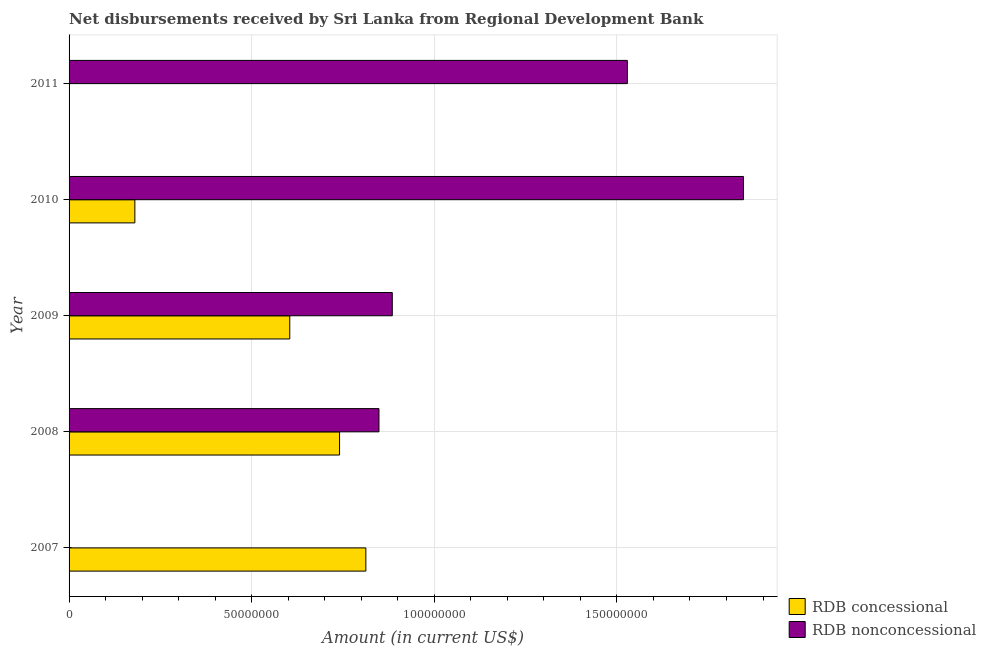How many bars are there on the 3rd tick from the top?
Your response must be concise. 2. What is the label of the 5th group of bars from the top?
Your answer should be compact. 2007. In how many cases, is the number of bars for a given year not equal to the number of legend labels?
Keep it short and to the point. 2. What is the net concessional disbursements from rdb in 2010?
Give a very brief answer. 1.80e+07. Across all years, what is the maximum net non concessional disbursements from rdb?
Your response must be concise. 1.85e+08. Across all years, what is the minimum net concessional disbursements from rdb?
Your response must be concise. 0. What is the total net non concessional disbursements from rdb in the graph?
Give a very brief answer. 5.11e+08. What is the difference between the net concessional disbursements from rdb in 2009 and that in 2010?
Offer a very short reply. 4.24e+07. What is the difference between the net concessional disbursements from rdb in 2007 and the net non concessional disbursements from rdb in 2010?
Your response must be concise. -1.03e+08. What is the average net concessional disbursements from rdb per year?
Give a very brief answer. 4.67e+07. In the year 2010, what is the difference between the net non concessional disbursements from rdb and net concessional disbursements from rdb?
Provide a short and direct response. 1.67e+08. What is the ratio of the net non concessional disbursements from rdb in 2009 to that in 2011?
Keep it short and to the point. 0.58. Is the net concessional disbursements from rdb in 2008 less than that in 2010?
Make the answer very short. No. What is the difference between the highest and the second highest net non concessional disbursements from rdb?
Offer a terse response. 3.18e+07. What is the difference between the highest and the lowest net concessional disbursements from rdb?
Make the answer very short. 8.13e+07. Are all the bars in the graph horizontal?
Provide a short and direct response. Yes. What is the difference between two consecutive major ticks on the X-axis?
Make the answer very short. 5.00e+07. Are the values on the major ticks of X-axis written in scientific E-notation?
Your answer should be very brief. No. Does the graph contain grids?
Make the answer very short. Yes. Where does the legend appear in the graph?
Offer a very short reply. Bottom right. What is the title of the graph?
Give a very brief answer. Net disbursements received by Sri Lanka from Regional Development Bank. Does "Non-pregnant women" appear as one of the legend labels in the graph?
Your answer should be compact. No. What is the label or title of the X-axis?
Give a very brief answer. Amount (in current US$). What is the label or title of the Y-axis?
Your answer should be very brief. Year. What is the Amount (in current US$) in RDB concessional in 2007?
Make the answer very short. 8.13e+07. What is the Amount (in current US$) of RDB nonconcessional in 2007?
Ensure brevity in your answer.  0. What is the Amount (in current US$) of RDB concessional in 2008?
Provide a succinct answer. 7.41e+07. What is the Amount (in current US$) of RDB nonconcessional in 2008?
Offer a terse response. 8.48e+07. What is the Amount (in current US$) of RDB concessional in 2009?
Give a very brief answer. 6.04e+07. What is the Amount (in current US$) of RDB nonconcessional in 2009?
Give a very brief answer. 8.85e+07. What is the Amount (in current US$) of RDB concessional in 2010?
Your answer should be very brief. 1.80e+07. What is the Amount (in current US$) of RDB nonconcessional in 2010?
Make the answer very short. 1.85e+08. What is the Amount (in current US$) of RDB nonconcessional in 2011?
Ensure brevity in your answer.  1.53e+08. Across all years, what is the maximum Amount (in current US$) in RDB concessional?
Offer a very short reply. 8.13e+07. Across all years, what is the maximum Amount (in current US$) of RDB nonconcessional?
Provide a succinct answer. 1.85e+08. Across all years, what is the minimum Amount (in current US$) in RDB nonconcessional?
Offer a terse response. 0. What is the total Amount (in current US$) of RDB concessional in the graph?
Provide a succinct answer. 2.34e+08. What is the total Amount (in current US$) of RDB nonconcessional in the graph?
Keep it short and to the point. 5.11e+08. What is the difference between the Amount (in current US$) of RDB concessional in 2007 and that in 2008?
Keep it short and to the point. 7.20e+06. What is the difference between the Amount (in current US$) of RDB concessional in 2007 and that in 2009?
Provide a short and direct response. 2.08e+07. What is the difference between the Amount (in current US$) in RDB concessional in 2007 and that in 2010?
Your answer should be very brief. 6.32e+07. What is the difference between the Amount (in current US$) of RDB concessional in 2008 and that in 2009?
Keep it short and to the point. 1.36e+07. What is the difference between the Amount (in current US$) of RDB nonconcessional in 2008 and that in 2009?
Provide a short and direct response. -3.64e+06. What is the difference between the Amount (in current US$) in RDB concessional in 2008 and that in 2010?
Your answer should be very brief. 5.60e+07. What is the difference between the Amount (in current US$) of RDB nonconcessional in 2008 and that in 2010?
Offer a very short reply. -9.98e+07. What is the difference between the Amount (in current US$) in RDB nonconcessional in 2008 and that in 2011?
Your response must be concise. -6.80e+07. What is the difference between the Amount (in current US$) of RDB concessional in 2009 and that in 2010?
Offer a terse response. 4.24e+07. What is the difference between the Amount (in current US$) of RDB nonconcessional in 2009 and that in 2010?
Give a very brief answer. -9.62e+07. What is the difference between the Amount (in current US$) of RDB nonconcessional in 2009 and that in 2011?
Provide a succinct answer. -6.44e+07. What is the difference between the Amount (in current US$) of RDB nonconcessional in 2010 and that in 2011?
Keep it short and to the point. 3.18e+07. What is the difference between the Amount (in current US$) of RDB concessional in 2007 and the Amount (in current US$) of RDB nonconcessional in 2008?
Keep it short and to the point. -3.59e+06. What is the difference between the Amount (in current US$) of RDB concessional in 2007 and the Amount (in current US$) of RDB nonconcessional in 2009?
Ensure brevity in your answer.  -7.24e+06. What is the difference between the Amount (in current US$) in RDB concessional in 2007 and the Amount (in current US$) in RDB nonconcessional in 2010?
Ensure brevity in your answer.  -1.03e+08. What is the difference between the Amount (in current US$) of RDB concessional in 2007 and the Amount (in current US$) of RDB nonconcessional in 2011?
Ensure brevity in your answer.  -7.16e+07. What is the difference between the Amount (in current US$) in RDB concessional in 2008 and the Amount (in current US$) in RDB nonconcessional in 2009?
Keep it short and to the point. -1.44e+07. What is the difference between the Amount (in current US$) of RDB concessional in 2008 and the Amount (in current US$) of RDB nonconcessional in 2010?
Provide a succinct answer. -1.11e+08. What is the difference between the Amount (in current US$) in RDB concessional in 2008 and the Amount (in current US$) in RDB nonconcessional in 2011?
Offer a very short reply. -7.88e+07. What is the difference between the Amount (in current US$) in RDB concessional in 2009 and the Amount (in current US$) in RDB nonconcessional in 2010?
Ensure brevity in your answer.  -1.24e+08. What is the difference between the Amount (in current US$) of RDB concessional in 2009 and the Amount (in current US$) of RDB nonconcessional in 2011?
Ensure brevity in your answer.  -9.24e+07. What is the difference between the Amount (in current US$) in RDB concessional in 2010 and the Amount (in current US$) in RDB nonconcessional in 2011?
Make the answer very short. -1.35e+08. What is the average Amount (in current US$) of RDB concessional per year?
Provide a succinct answer. 4.67e+07. What is the average Amount (in current US$) in RDB nonconcessional per year?
Your response must be concise. 1.02e+08. In the year 2008, what is the difference between the Amount (in current US$) in RDB concessional and Amount (in current US$) in RDB nonconcessional?
Offer a terse response. -1.08e+07. In the year 2009, what is the difference between the Amount (in current US$) of RDB concessional and Amount (in current US$) of RDB nonconcessional?
Keep it short and to the point. -2.81e+07. In the year 2010, what is the difference between the Amount (in current US$) in RDB concessional and Amount (in current US$) in RDB nonconcessional?
Provide a succinct answer. -1.67e+08. What is the ratio of the Amount (in current US$) in RDB concessional in 2007 to that in 2008?
Your answer should be very brief. 1.1. What is the ratio of the Amount (in current US$) of RDB concessional in 2007 to that in 2009?
Your answer should be very brief. 1.34. What is the ratio of the Amount (in current US$) in RDB concessional in 2007 to that in 2010?
Keep it short and to the point. 4.51. What is the ratio of the Amount (in current US$) in RDB concessional in 2008 to that in 2009?
Make the answer very short. 1.23. What is the ratio of the Amount (in current US$) in RDB nonconcessional in 2008 to that in 2009?
Offer a very short reply. 0.96. What is the ratio of the Amount (in current US$) of RDB concessional in 2008 to that in 2010?
Offer a very short reply. 4.11. What is the ratio of the Amount (in current US$) of RDB nonconcessional in 2008 to that in 2010?
Your answer should be very brief. 0.46. What is the ratio of the Amount (in current US$) in RDB nonconcessional in 2008 to that in 2011?
Give a very brief answer. 0.56. What is the ratio of the Amount (in current US$) in RDB concessional in 2009 to that in 2010?
Your answer should be very brief. 3.35. What is the ratio of the Amount (in current US$) in RDB nonconcessional in 2009 to that in 2010?
Your answer should be compact. 0.48. What is the ratio of the Amount (in current US$) in RDB nonconcessional in 2009 to that in 2011?
Keep it short and to the point. 0.58. What is the ratio of the Amount (in current US$) in RDB nonconcessional in 2010 to that in 2011?
Provide a succinct answer. 1.21. What is the difference between the highest and the second highest Amount (in current US$) of RDB concessional?
Make the answer very short. 7.20e+06. What is the difference between the highest and the second highest Amount (in current US$) in RDB nonconcessional?
Your answer should be very brief. 3.18e+07. What is the difference between the highest and the lowest Amount (in current US$) in RDB concessional?
Keep it short and to the point. 8.13e+07. What is the difference between the highest and the lowest Amount (in current US$) in RDB nonconcessional?
Give a very brief answer. 1.85e+08. 